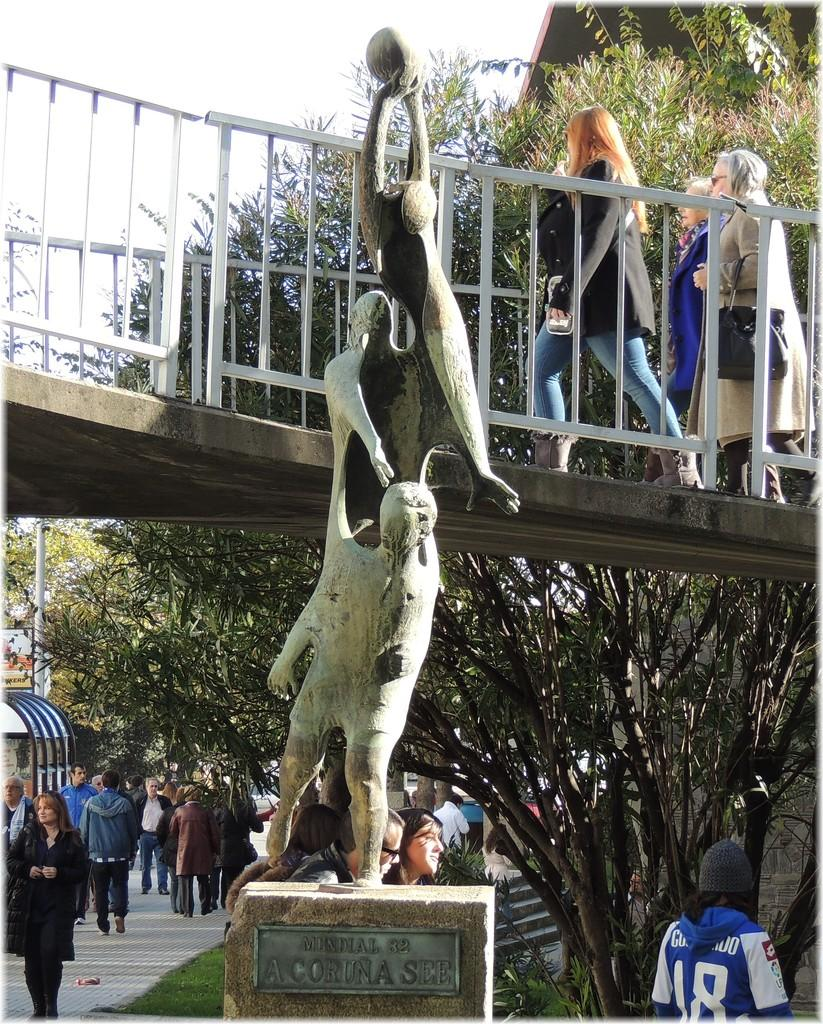<image>
Provide a brief description of the given image. An attraction at this park is a statue labeled Mundial 82 A Coruna See 